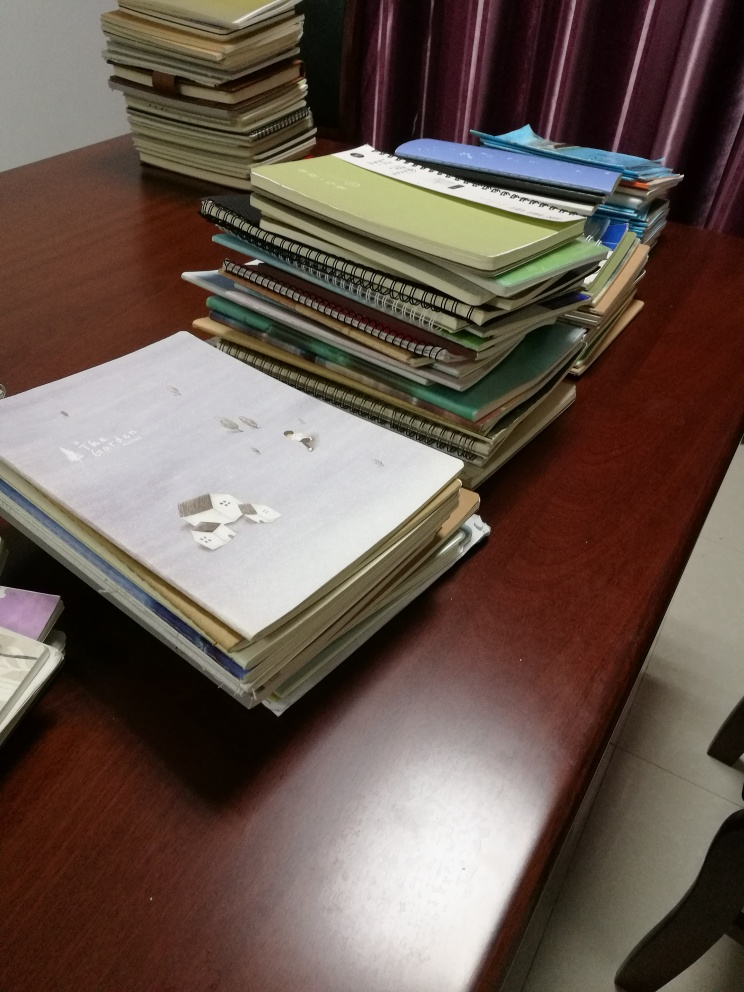Is there any blurriness in the image?
 No 